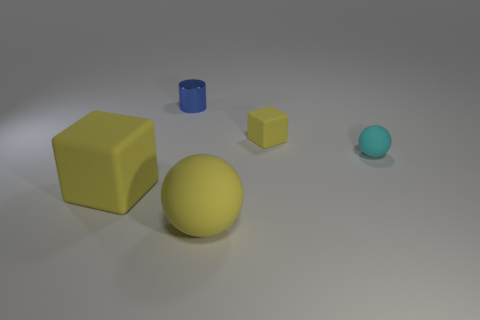Is the number of small objects that are to the right of the big yellow rubber sphere greater than the number of yellow blocks? No, the number of small objects to the right of the large yellow sphere is not greater than the number of yellow blocks. There is only one small object, a blue cylinder, to the right of the yellow sphere, while there are two yellow blocks depicted in the image. 